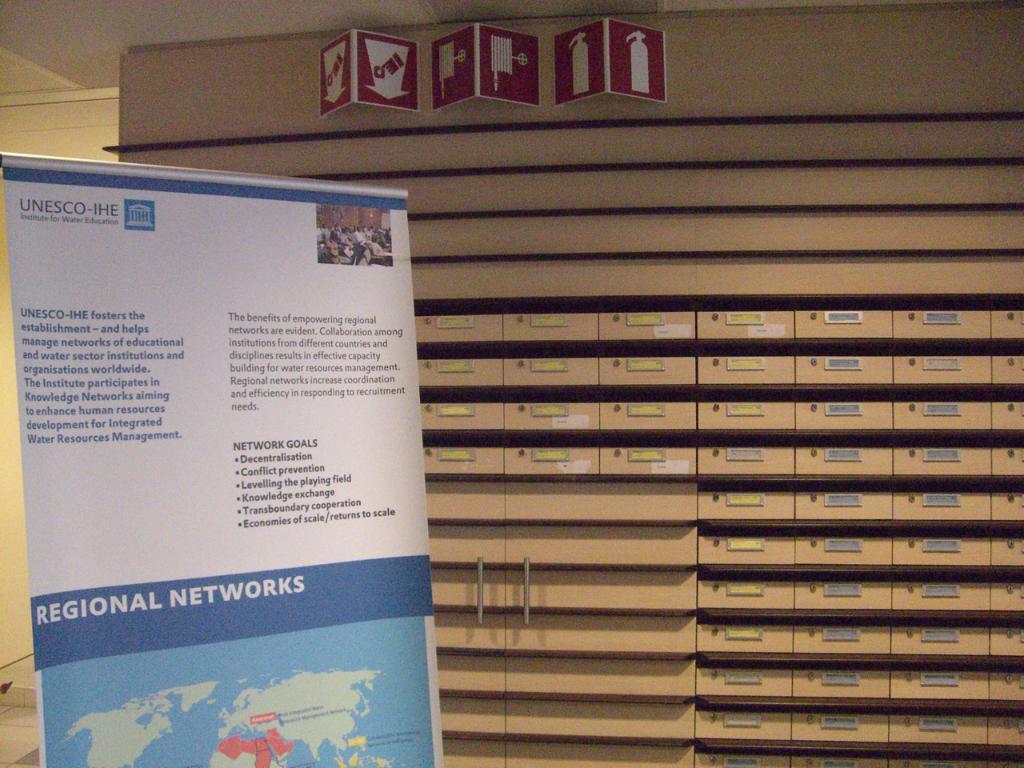What kind of networks is this?
Your answer should be very brief. Regional. 